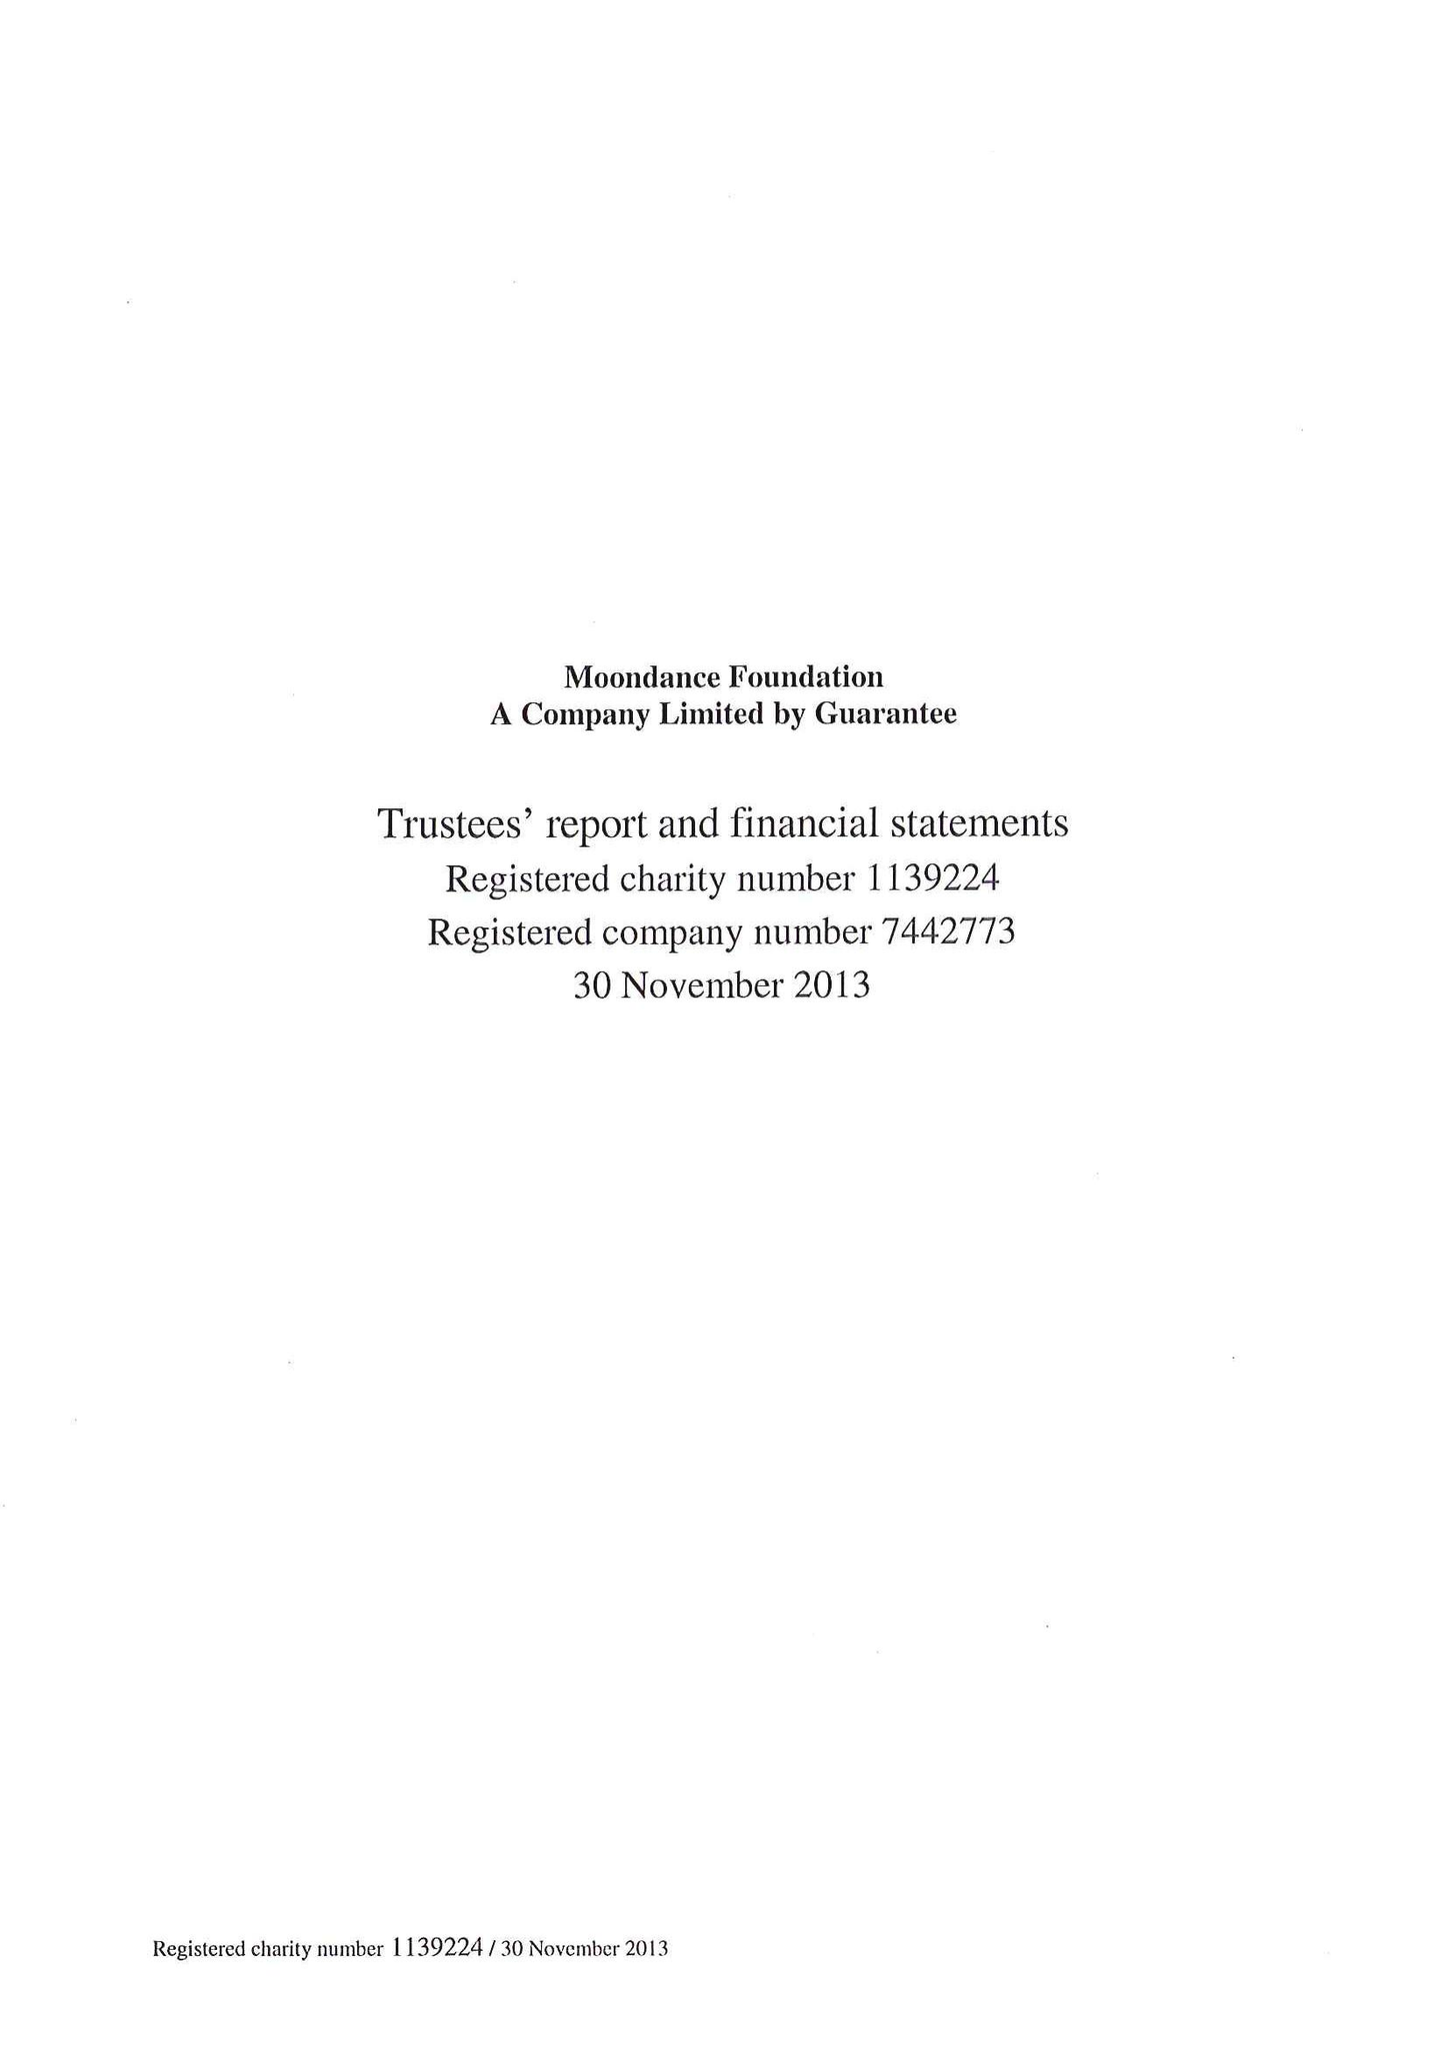What is the value for the address__street_line?
Answer the question using a single word or phrase. 1-3 WATERS LANE 